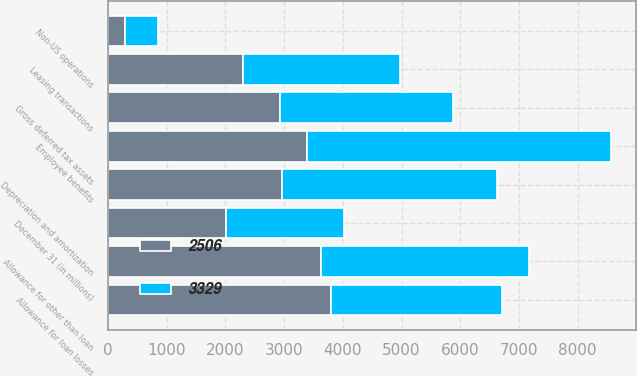Convert chart to OTSL. <chart><loc_0><loc_0><loc_500><loc_500><stacked_bar_chart><ecel><fcel>December 31 (in millions)<fcel>Allowance for loan losses<fcel>Allowance for other than loan<fcel>Employee benefits<fcel>Non-US operations<fcel>Gross deferred tax assets<fcel>Depreciation and amortization<fcel>Leasing transactions<nl><fcel>2506<fcel>2007<fcel>3800<fcel>3635<fcel>3391<fcel>285<fcel>2938<fcel>2966<fcel>2304<nl><fcel>3329<fcel>2006<fcel>2910<fcel>3533<fcel>5175<fcel>566<fcel>2938<fcel>3668<fcel>2675<nl></chart> 